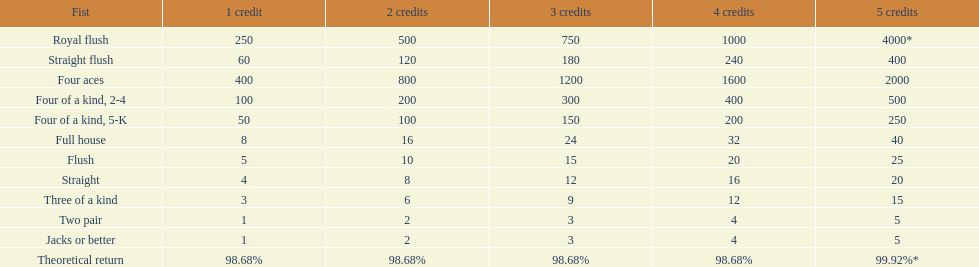How many straight wins at 3 credits equals one straight flush win at two credits? 10. 